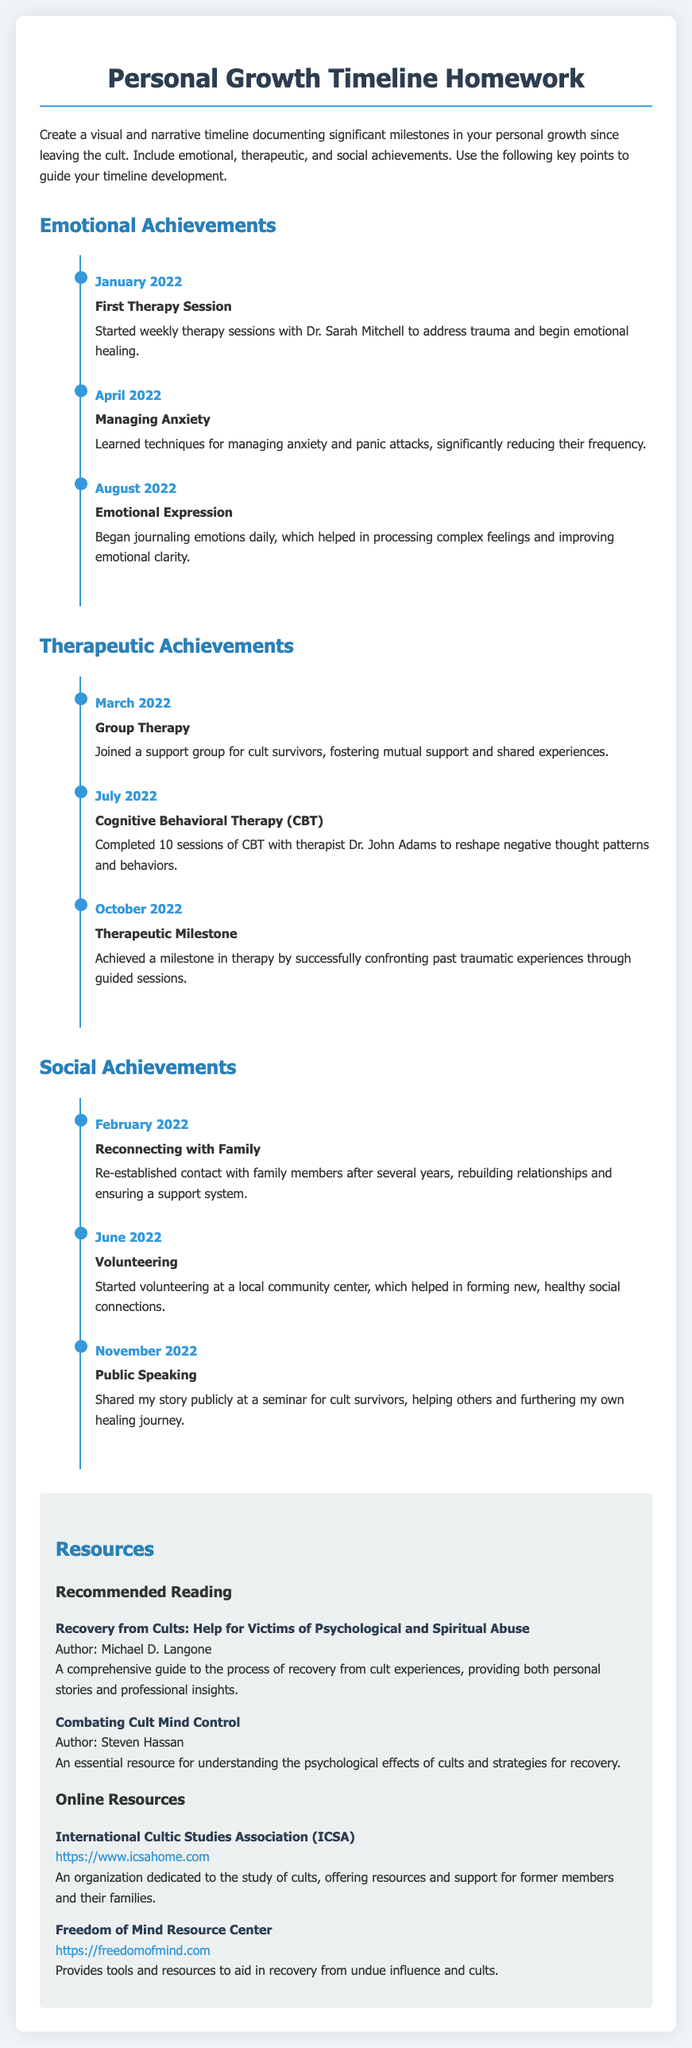What month did the first therapy session occur? The document states that the first therapy session took place in January 2022.
Answer: January 2022 What therapeutic approach was completed in July 2022? According to the document, Cognitive Behavioral Therapy (CBT) was completed in July 2022.
Answer: Cognitive Behavioral Therapy (CBT) How many sessions of CBT were completed? The document mentions that 10 sessions of CBT were completed.
Answer: 10 sessions What significant emotional achievement was documented in August 2022? The document indicates that the significant achievement was Emotional Expression, related to journaling emotions daily.
Answer: Emotional Expression Which resource is focused on understanding psychological effects of cults? The document details that "Combating Cult Mind Control" is focused on psychological effects of cults.
Answer: Combating Cult Mind Control In which month did the individual start volunteering? The document states that volunteering started in June 2022.
Answer: June 2022 What is a recommended online resource mentioned in the document? The document provides the International Cultic Studies Association (ICSA) as a recommended online resource.
Answer: International Cultic Studies Association (ICSA) What was a key social achievement noted in November 2022? The document notes that Public Speaking, sharing a story at a seminar for cult survivors, was a key social achievement.
Answer: Public Speaking 